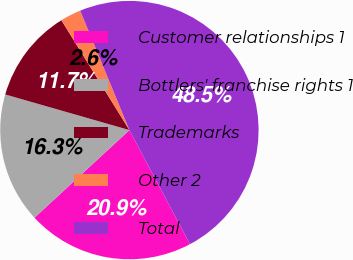Convert chart. <chart><loc_0><loc_0><loc_500><loc_500><pie_chart><fcel>Customer relationships 1<fcel>Bottlers' franchise rights 1<fcel>Trademarks<fcel>Other 2<fcel>Total<nl><fcel>20.9%<fcel>16.31%<fcel>11.73%<fcel>2.6%<fcel>48.46%<nl></chart> 